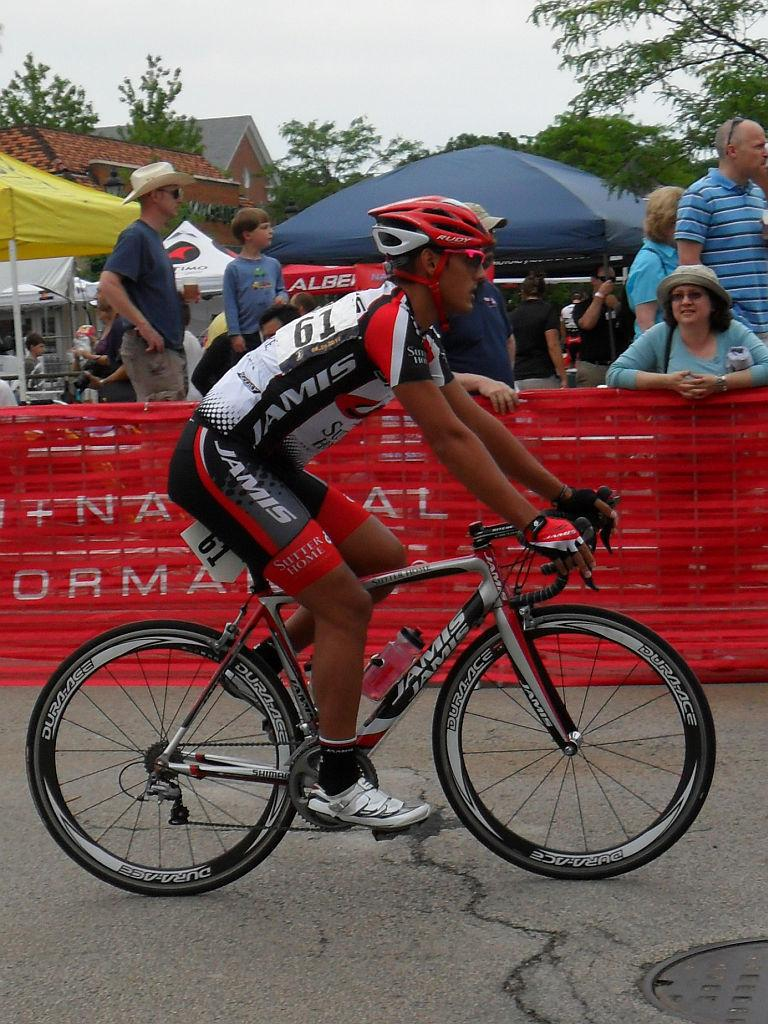What is the main subject of the image? There is a man in the image. What is the man doing in the image? The man is on a cycle. What can be seen in the background of the image? There are people, umbrellas, buildings, trees, and the sky visible in the background of the image. What type of soap is the man using to clean the chain on his cycle in the image? There is no soap or chain present in the image; the man is simply riding a cycle. What is the man's home like in the image? The image does not show the man's home or provide any information about it. 